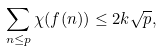<formula> <loc_0><loc_0><loc_500><loc_500>\sum _ { n \leq p } \chi ( f ( n ) ) \leq 2 k \sqrt { p } ,</formula> 